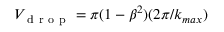Convert formula to latex. <formula><loc_0><loc_0><loc_500><loc_500>V _ { d r o p } = \pi ( 1 - \beta ^ { 2 } ) ( 2 \pi / k _ { \max } )</formula> 